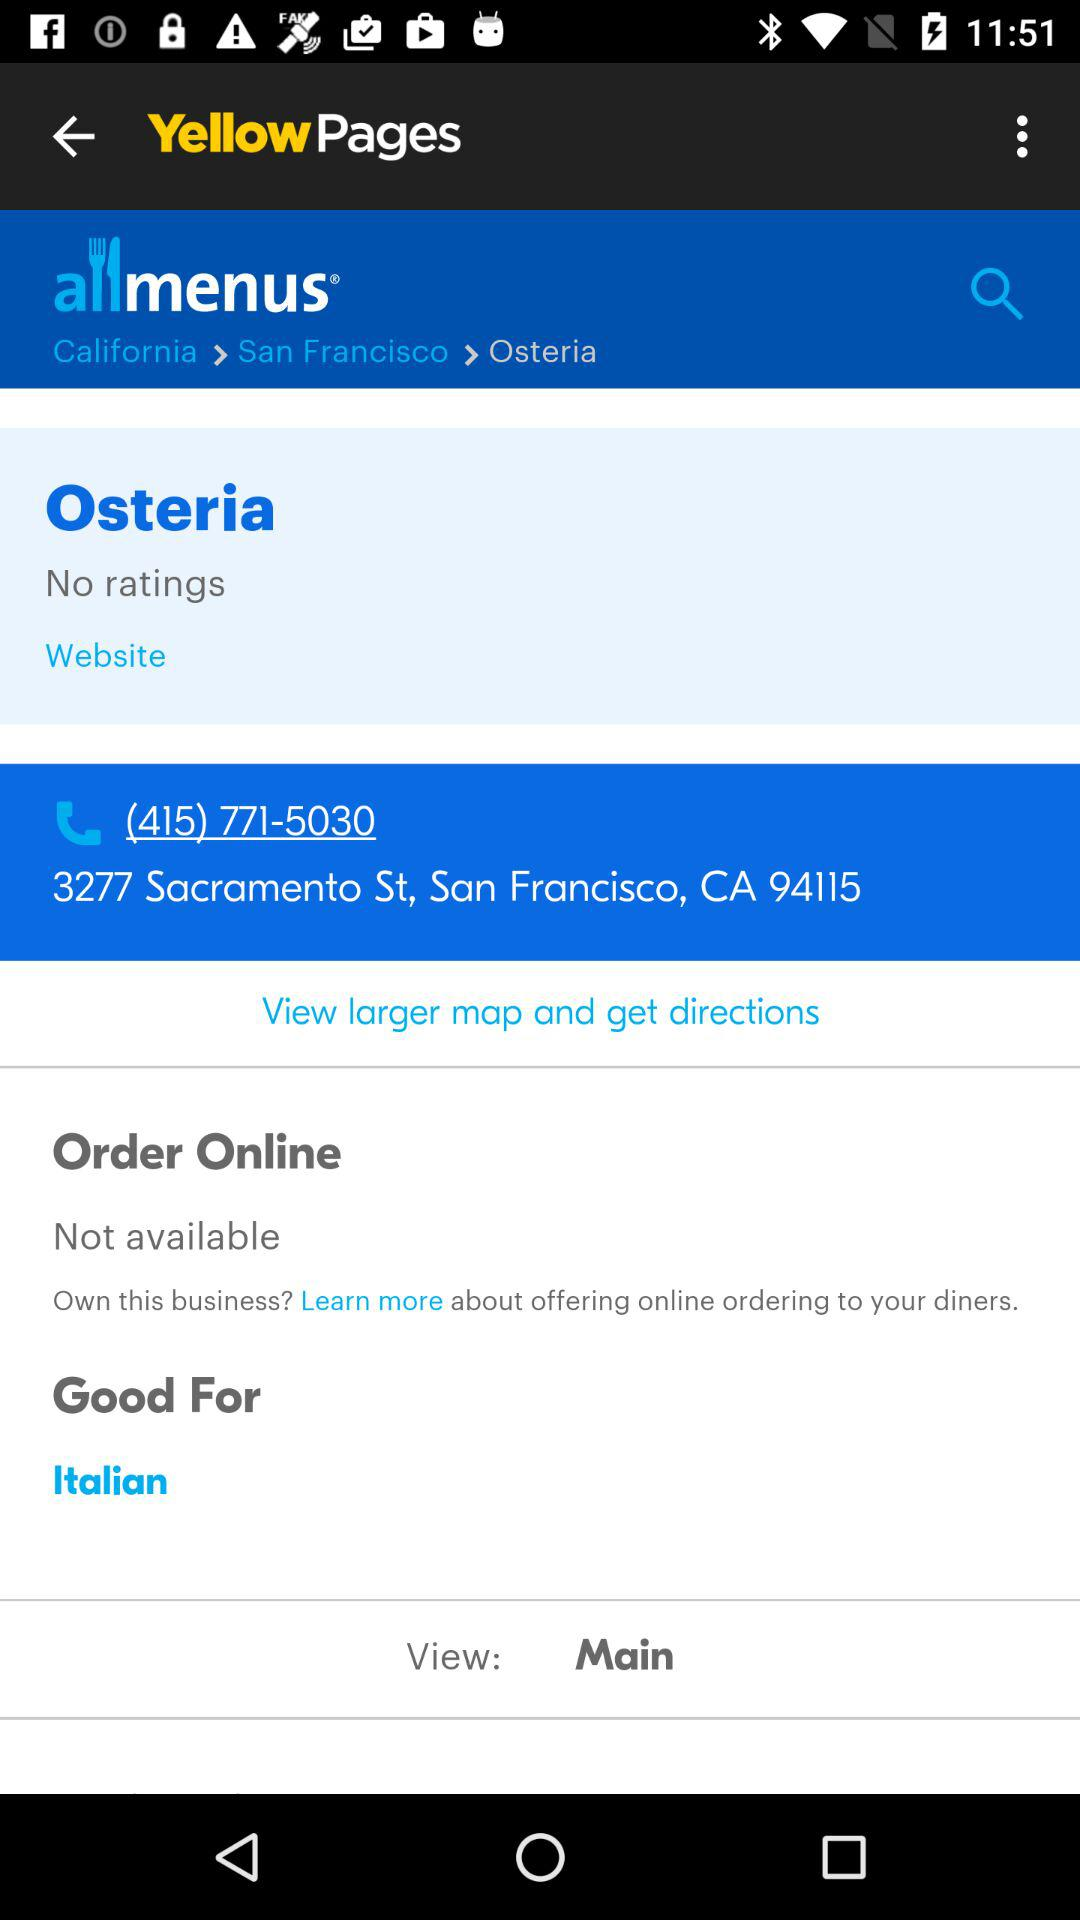Is there an online order available? An online order is not available. 